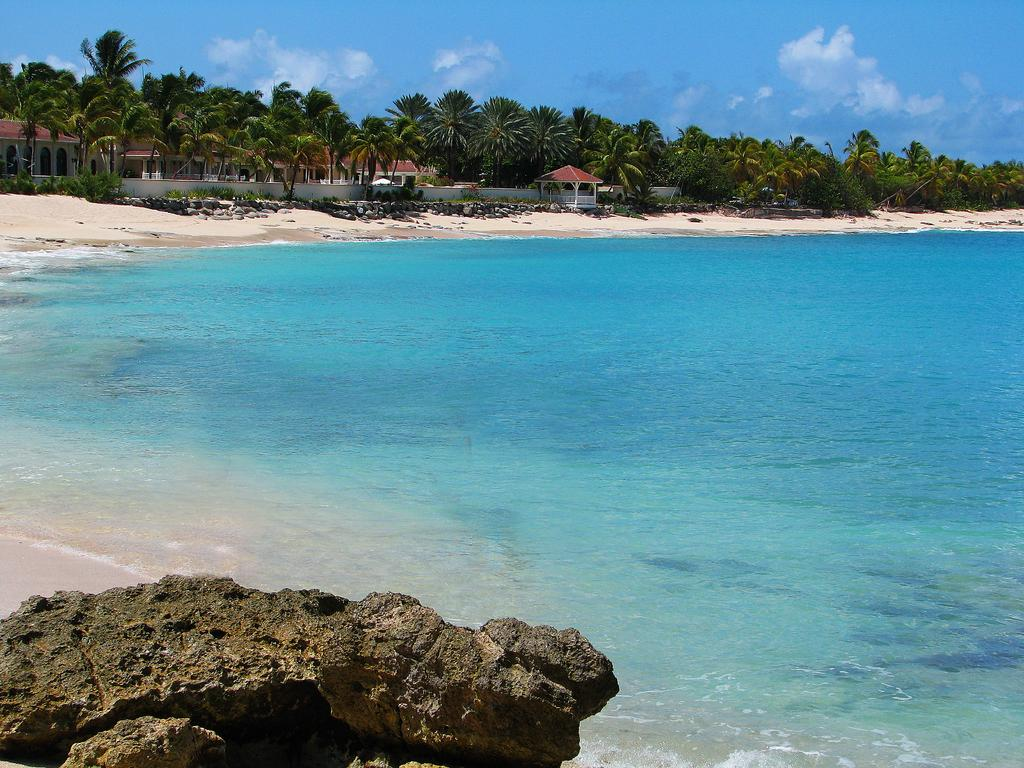What type of structures can be seen in the image? There are buildings in the image. What natural elements are present in the image? There are trees and water visible in the image. Can you describe any other objects in the image? There is a rock in the image. How would you describe the sky in the image? The sky is blue and cloudy. What type of cloth is being used to make the bubbles in the image? There are no bubbles present in the image, so there is no cloth being used to make bubbles. 